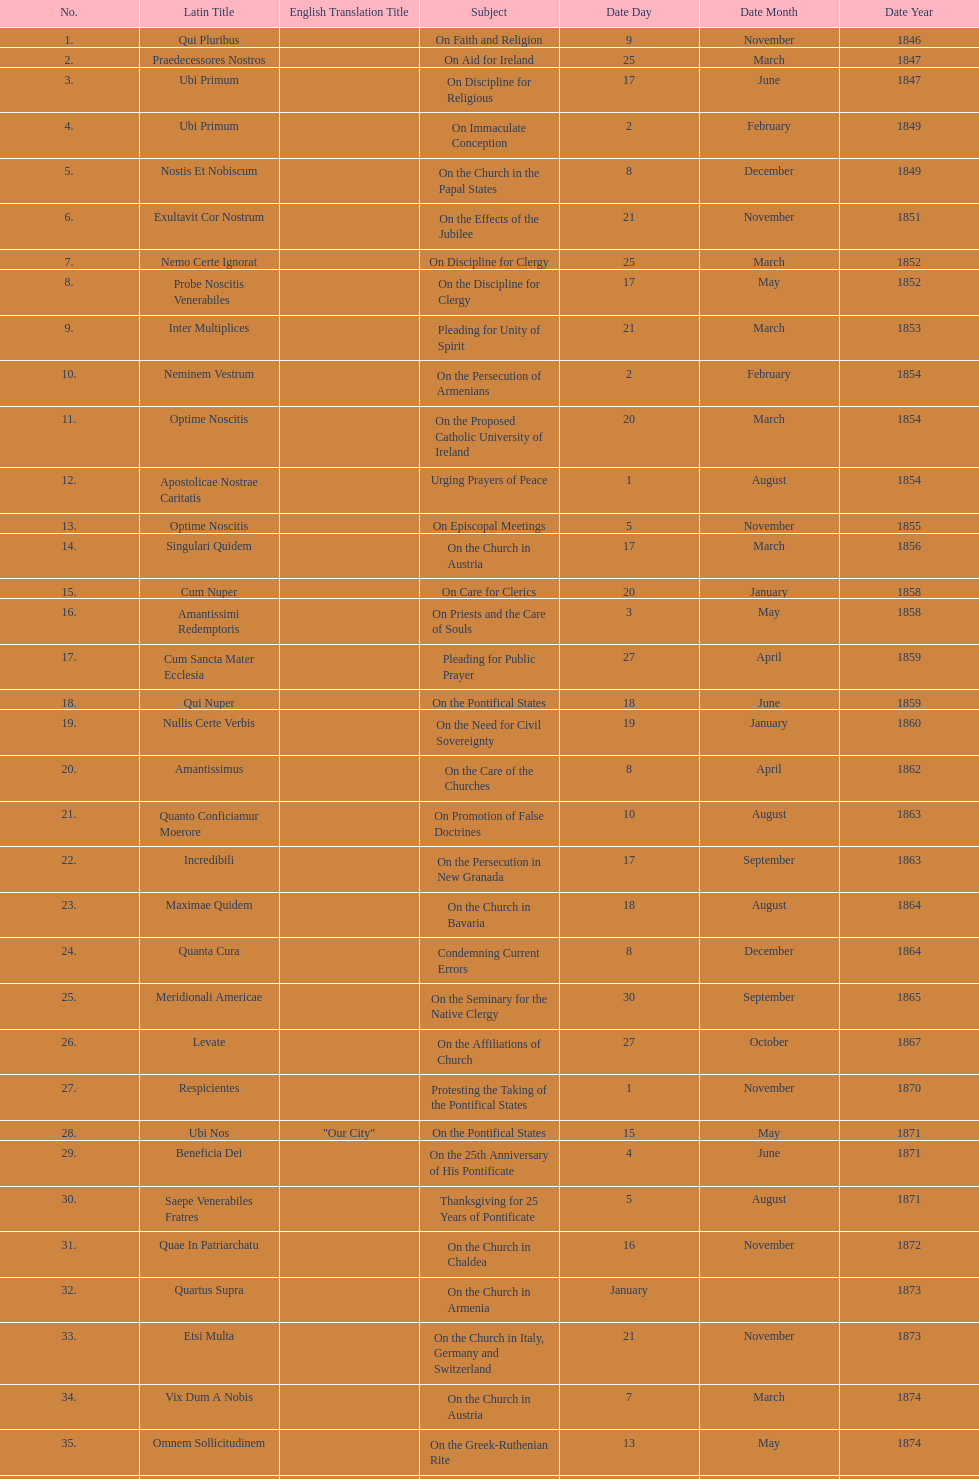Latin title of the encyclical before the encyclical with the subject "on the church in bavaria" Incredibili. 